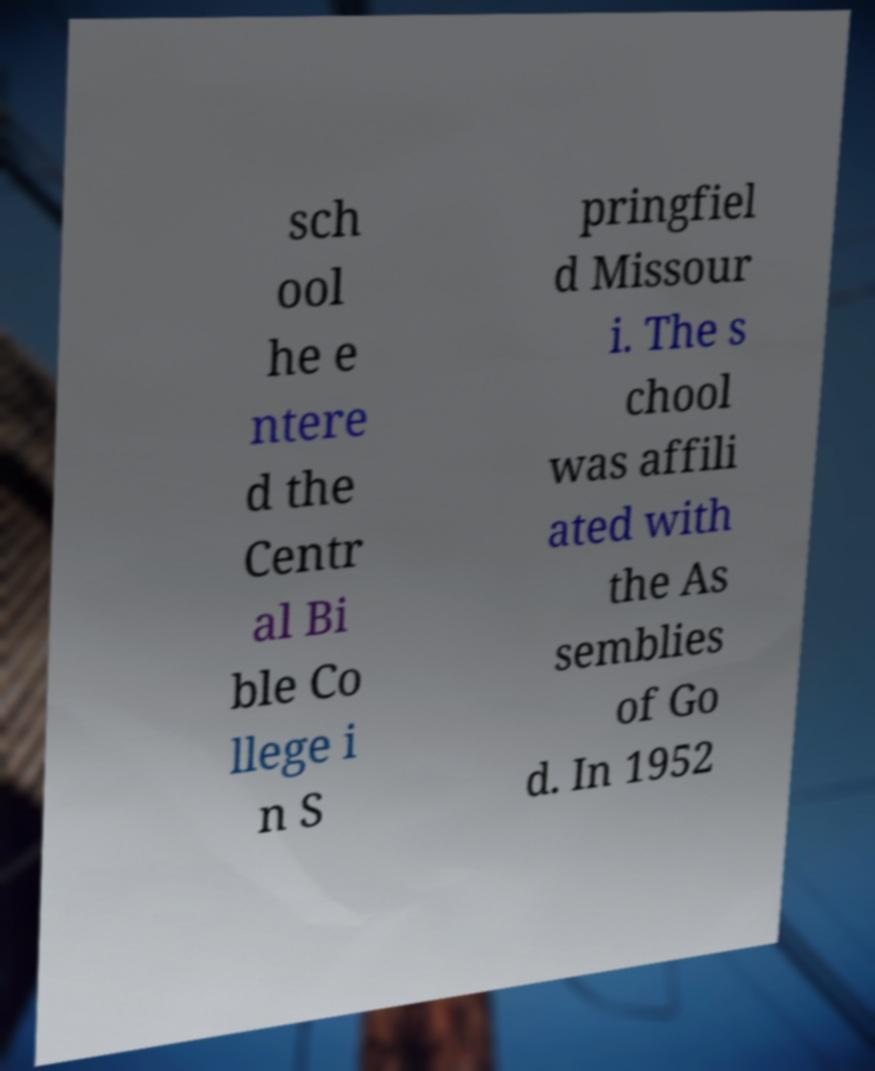I need the written content from this picture converted into text. Can you do that? sch ool he e ntere d the Centr al Bi ble Co llege i n S pringfiel d Missour i. The s chool was affili ated with the As semblies of Go d. In 1952 